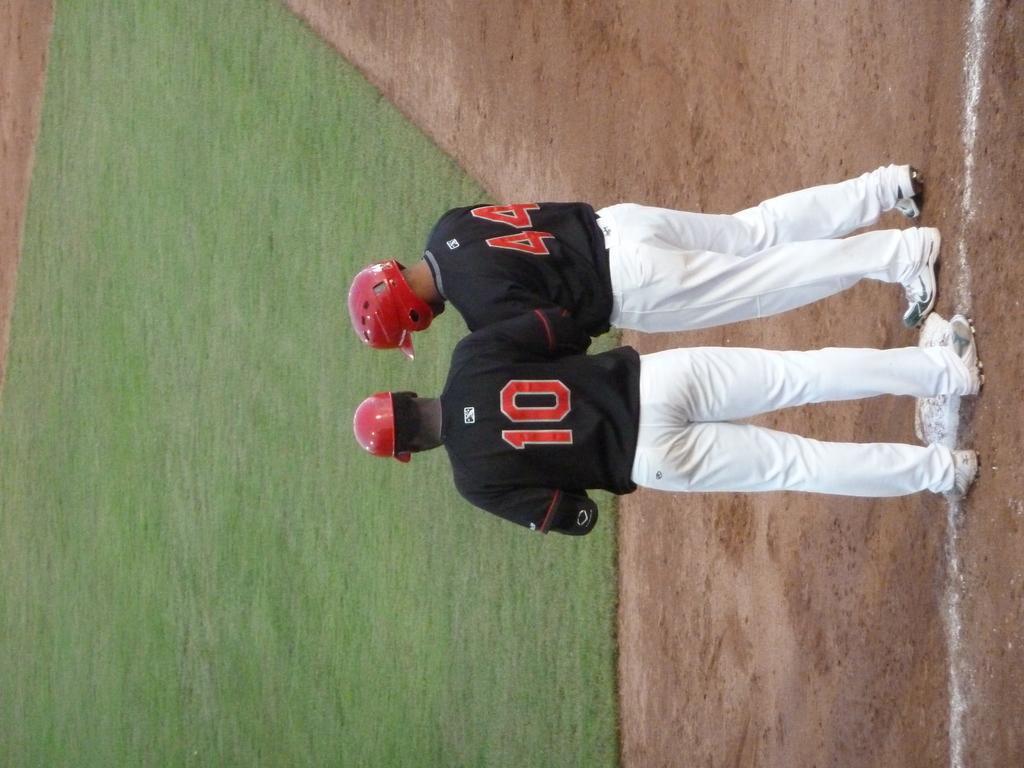Is 44 on the field?
Keep it short and to the point. Yes. 